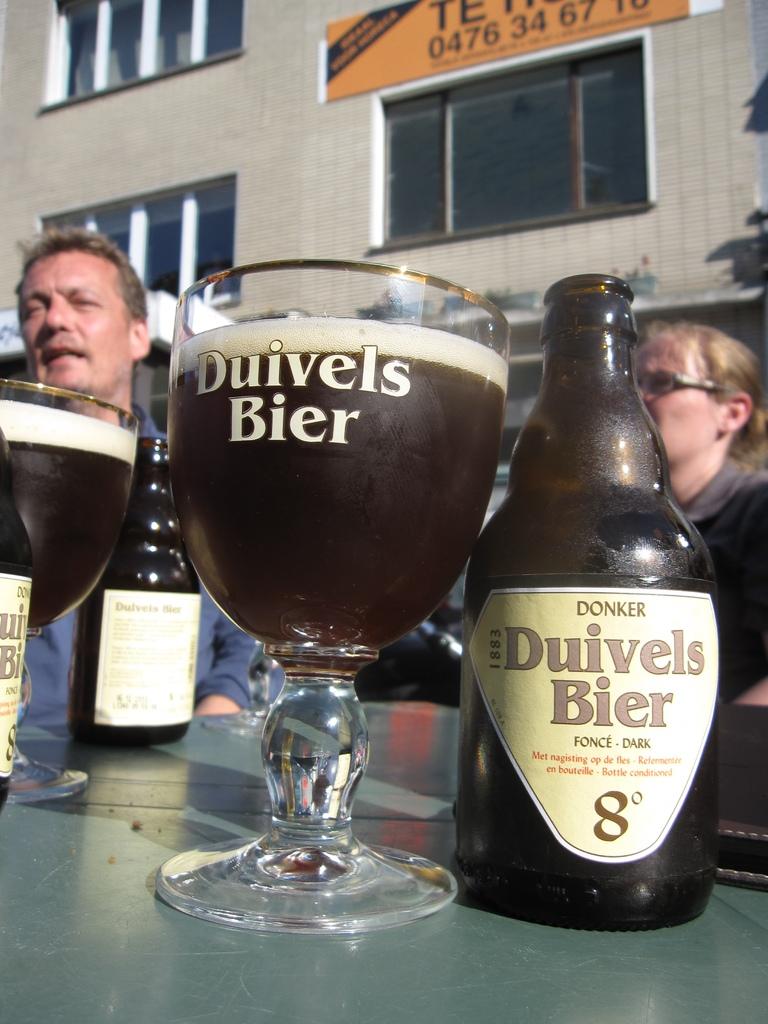What number does it say on the bottle?
Your response must be concise. 8. 